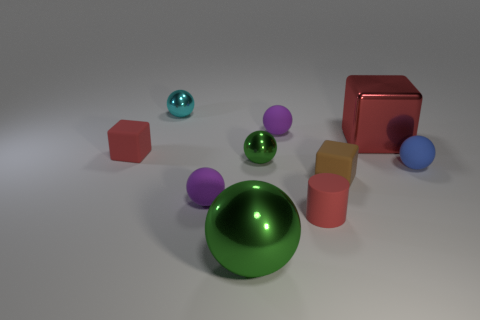Subtract all metal blocks. How many blocks are left? 2 Subtract all cyan balls. How many balls are left? 5 Subtract all purple spheres. How many red blocks are left? 2 Subtract all cubes. How many objects are left? 7 Subtract all gray balls. Subtract all purple cylinders. How many balls are left? 6 Subtract all large red metal cubes. Subtract all small red matte cylinders. How many objects are left? 8 Add 4 tiny red rubber objects. How many tiny red rubber objects are left? 6 Add 2 gray things. How many gray things exist? 2 Subtract 0 purple blocks. How many objects are left? 10 Subtract 1 cylinders. How many cylinders are left? 0 